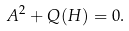<formula> <loc_0><loc_0><loc_500><loc_500>A ^ { 2 } + Q ( H ) = 0 .</formula> 